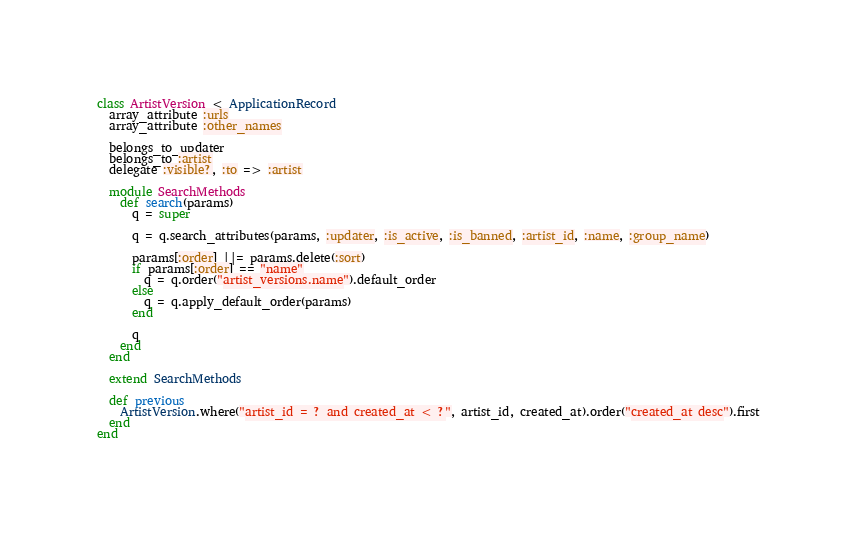Convert code to text. <code><loc_0><loc_0><loc_500><loc_500><_Ruby_>class ArtistVersion < ApplicationRecord
  array_attribute :urls
  array_attribute :other_names

  belongs_to_updater
  belongs_to :artist
  delegate :visible?, :to => :artist

  module SearchMethods
    def search(params)
      q = super

      q = q.search_attributes(params, :updater, :is_active, :is_banned, :artist_id, :name, :group_name)

      params[:order] ||= params.delete(:sort)
      if params[:order] == "name"
        q = q.order("artist_versions.name").default_order
      else
        q = q.apply_default_order(params)
      end

      q
    end
  end

  extend SearchMethods

  def previous
    ArtistVersion.where("artist_id = ? and created_at < ?", artist_id, created_at).order("created_at desc").first
  end
end
</code> 